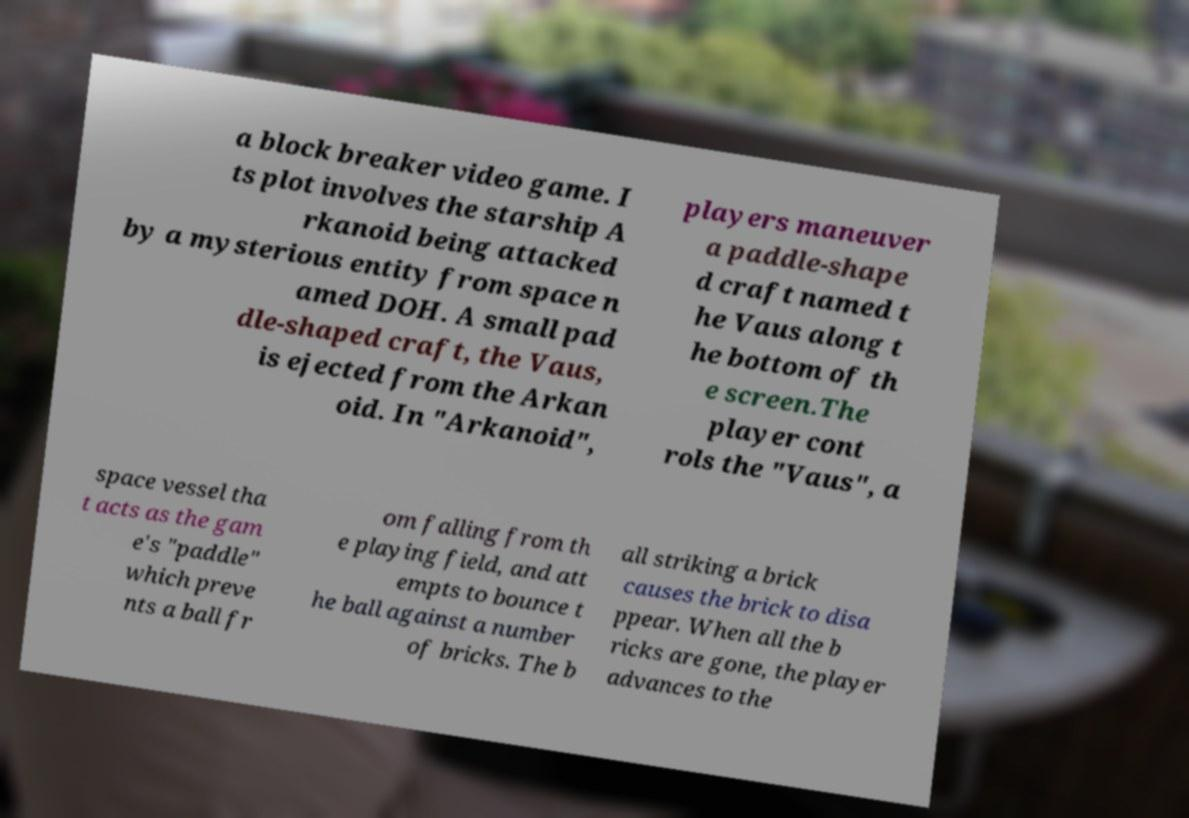Please read and relay the text visible in this image. What does it say? a block breaker video game. I ts plot involves the starship A rkanoid being attacked by a mysterious entity from space n amed DOH. A small pad dle-shaped craft, the Vaus, is ejected from the Arkan oid. In "Arkanoid", players maneuver a paddle-shape d craft named t he Vaus along t he bottom of th e screen.The player cont rols the "Vaus", a space vessel tha t acts as the gam e's "paddle" which preve nts a ball fr om falling from th e playing field, and att empts to bounce t he ball against a number of bricks. The b all striking a brick causes the brick to disa ppear. When all the b ricks are gone, the player advances to the 